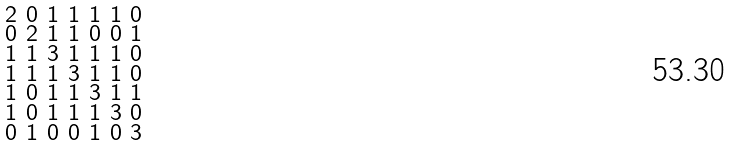Convert formula to latex. <formula><loc_0><loc_0><loc_500><loc_500>\begin{smallmatrix} 2 & 0 & 1 & 1 & 1 & 1 & 0 \\ 0 & 2 & 1 & 1 & 0 & 0 & 1 \\ 1 & 1 & 3 & 1 & 1 & 1 & 0 \\ 1 & 1 & 1 & 3 & 1 & 1 & 0 \\ 1 & 0 & 1 & 1 & 3 & 1 & 1 \\ 1 & 0 & 1 & 1 & 1 & 3 & 0 \\ 0 & 1 & 0 & 0 & 1 & 0 & 3 \end{smallmatrix}</formula> 